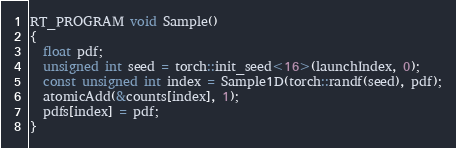Convert code to text. <code><loc_0><loc_0><loc_500><loc_500><_Cuda_>
RT_PROGRAM void Sample()
{
  float pdf;
  unsigned int seed = torch::init_seed<16>(launchIndex, 0);
  const unsigned int index = Sample1D(torch::randf(seed), pdf);
  atomicAdd(&counts[index], 1);
  pdfs[index] = pdf;
}</code> 